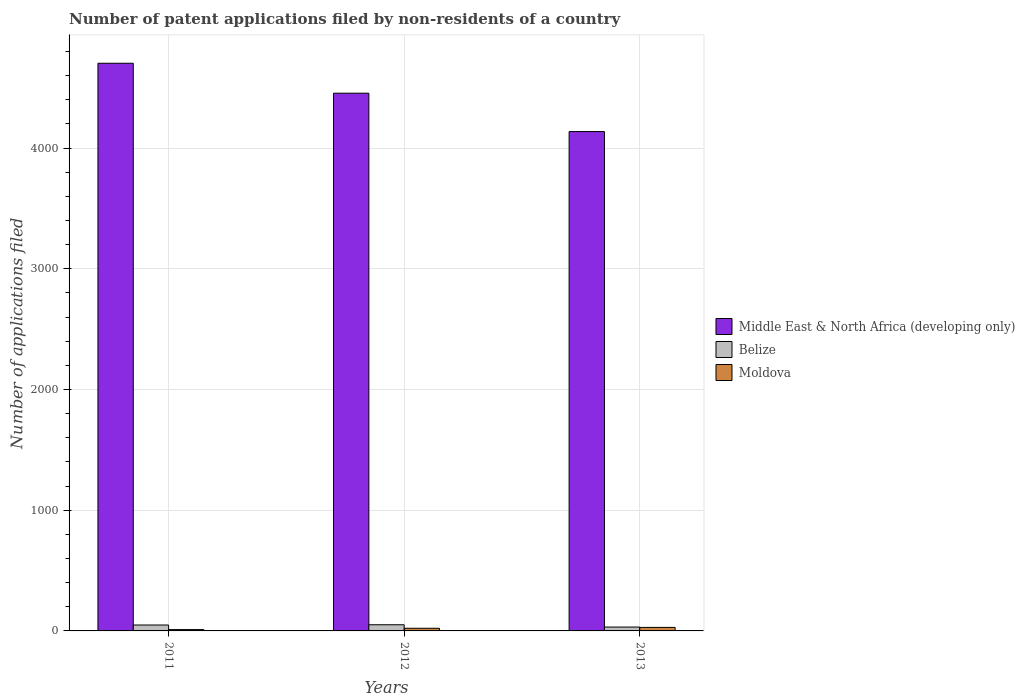How many groups of bars are there?
Keep it short and to the point. 3. What is the number of applications filed in Belize in 2011?
Ensure brevity in your answer.  49. Across all years, what is the maximum number of applications filed in Middle East & North Africa (developing only)?
Give a very brief answer. 4703. Across all years, what is the minimum number of applications filed in Middle East & North Africa (developing only)?
Keep it short and to the point. 4137. In which year was the number of applications filed in Moldova maximum?
Provide a succinct answer. 2013. In which year was the number of applications filed in Belize minimum?
Make the answer very short. 2013. What is the total number of applications filed in Middle East & North Africa (developing only) in the graph?
Offer a very short reply. 1.33e+04. What is the difference between the number of applications filed in Belize in 2011 and that in 2012?
Give a very brief answer. -2. What is the difference between the number of applications filed in Belize in 2011 and the number of applications filed in Middle East & North Africa (developing only) in 2013?
Your answer should be compact. -4088. What is the average number of applications filed in Belize per year?
Offer a terse response. 44. In the year 2011, what is the difference between the number of applications filed in Moldova and number of applications filed in Belize?
Give a very brief answer. -38. What is the ratio of the number of applications filed in Middle East & North Africa (developing only) in 2012 to that in 2013?
Ensure brevity in your answer.  1.08. Is the number of applications filed in Middle East & North Africa (developing only) in 2011 less than that in 2012?
Offer a very short reply. No. What is the difference between the highest and the second highest number of applications filed in Middle East & North Africa (developing only)?
Provide a succinct answer. 248. What does the 1st bar from the left in 2012 represents?
Make the answer very short. Middle East & North Africa (developing only). What does the 1st bar from the right in 2012 represents?
Provide a succinct answer. Moldova. Is it the case that in every year, the sum of the number of applications filed in Belize and number of applications filed in Middle East & North Africa (developing only) is greater than the number of applications filed in Moldova?
Keep it short and to the point. Yes. How many bars are there?
Offer a very short reply. 9. Are all the bars in the graph horizontal?
Offer a terse response. No. How many years are there in the graph?
Provide a succinct answer. 3. Does the graph contain any zero values?
Provide a short and direct response. No. Does the graph contain grids?
Your answer should be compact. Yes. What is the title of the graph?
Your response must be concise. Number of patent applications filed by non-residents of a country. What is the label or title of the X-axis?
Provide a short and direct response. Years. What is the label or title of the Y-axis?
Your answer should be compact. Number of applications filed. What is the Number of applications filed of Middle East & North Africa (developing only) in 2011?
Your response must be concise. 4703. What is the Number of applications filed of Moldova in 2011?
Keep it short and to the point. 11. What is the Number of applications filed in Middle East & North Africa (developing only) in 2012?
Your answer should be compact. 4455. What is the Number of applications filed of Belize in 2012?
Your answer should be very brief. 51. What is the Number of applications filed of Moldova in 2012?
Ensure brevity in your answer.  22. What is the Number of applications filed of Middle East & North Africa (developing only) in 2013?
Offer a terse response. 4137. What is the Number of applications filed in Belize in 2013?
Offer a terse response. 32. Across all years, what is the maximum Number of applications filed of Middle East & North Africa (developing only)?
Keep it short and to the point. 4703. Across all years, what is the maximum Number of applications filed in Belize?
Offer a terse response. 51. Across all years, what is the minimum Number of applications filed in Middle East & North Africa (developing only)?
Make the answer very short. 4137. Across all years, what is the minimum Number of applications filed in Belize?
Your response must be concise. 32. What is the total Number of applications filed of Middle East & North Africa (developing only) in the graph?
Your answer should be very brief. 1.33e+04. What is the total Number of applications filed of Belize in the graph?
Make the answer very short. 132. What is the total Number of applications filed of Moldova in the graph?
Your answer should be very brief. 62. What is the difference between the Number of applications filed of Middle East & North Africa (developing only) in 2011 and that in 2012?
Your answer should be compact. 248. What is the difference between the Number of applications filed of Middle East & North Africa (developing only) in 2011 and that in 2013?
Your answer should be very brief. 566. What is the difference between the Number of applications filed in Moldova in 2011 and that in 2013?
Provide a succinct answer. -18. What is the difference between the Number of applications filed in Middle East & North Africa (developing only) in 2012 and that in 2013?
Make the answer very short. 318. What is the difference between the Number of applications filed in Moldova in 2012 and that in 2013?
Give a very brief answer. -7. What is the difference between the Number of applications filed of Middle East & North Africa (developing only) in 2011 and the Number of applications filed of Belize in 2012?
Your answer should be very brief. 4652. What is the difference between the Number of applications filed of Middle East & North Africa (developing only) in 2011 and the Number of applications filed of Moldova in 2012?
Offer a very short reply. 4681. What is the difference between the Number of applications filed in Middle East & North Africa (developing only) in 2011 and the Number of applications filed in Belize in 2013?
Your answer should be compact. 4671. What is the difference between the Number of applications filed of Middle East & North Africa (developing only) in 2011 and the Number of applications filed of Moldova in 2013?
Your answer should be compact. 4674. What is the difference between the Number of applications filed of Belize in 2011 and the Number of applications filed of Moldova in 2013?
Provide a succinct answer. 20. What is the difference between the Number of applications filed of Middle East & North Africa (developing only) in 2012 and the Number of applications filed of Belize in 2013?
Make the answer very short. 4423. What is the difference between the Number of applications filed in Middle East & North Africa (developing only) in 2012 and the Number of applications filed in Moldova in 2013?
Ensure brevity in your answer.  4426. What is the average Number of applications filed of Middle East & North Africa (developing only) per year?
Give a very brief answer. 4431.67. What is the average Number of applications filed of Belize per year?
Your response must be concise. 44. What is the average Number of applications filed of Moldova per year?
Offer a very short reply. 20.67. In the year 2011, what is the difference between the Number of applications filed of Middle East & North Africa (developing only) and Number of applications filed of Belize?
Your answer should be compact. 4654. In the year 2011, what is the difference between the Number of applications filed in Middle East & North Africa (developing only) and Number of applications filed in Moldova?
Ensure brevity in your answer.  4692. In the year 2011, what is the difference between the Number of applications filed in Belize and Number of applications filed in Moldova?
Ensure brevity in your answer.  38. In the year 2012, what is the difference between the Number of applications filed of Middle East & North Africa (developing only) and Number of applications filed of Belize?
Your answer should be compact. 4404. In the year 2012, what is the difference between the Number of applications filed of Middle East & North Africa (developing only) and Number of applications filed of Moldova?
Your answer should be very brief. 4433. In the year 2012, what is the difference between the Number of applications filed in Belize and Number of applications filed in Moldova?
Offer a terse response. 29. In the year 2013, what is the difference between the Number of applications filed in Middle East & North Africa (developing only) and Number of applications filed in Belize?
Your answer should be very brief. 4105. In the year 2013, what is the difference between the Number of applications filed of Middle East & North Africa (developing only) and Number of applications filed of Moldova?
Your response must be concise. 4108. What is the ratio of the Number of applications filed in Middle East & North Africa (developing only) in 2011 to that in 2012?
Provide a succinct answer. 1.06. What is the ratio of the Number of applications filed of Belize in 2011 to that in 2012?
Provide a succinct answer. 0.96. What is the ratio of the Number of applications filed in Moldova in 2011 to that in 2012?
Keep it short and to the point. 0.5. What is the ratio of the Number of applications filed in Middle East & North Africa (developing only) in 2011 to that in 2013?
Your response must be concise. 1.14. What is the ratio of the Number of applications filed of Belize in 2011 to that in 2013?
Offer a very short reply. 1.53. What is the ratio of the Number of applications filed of Moldova in 2011 to that in 2013?
Offer a very short reply. 0.38. What is the ratio of the Number of applications filed in Middle East & North Africa (developing only) in 2012 to that in 2013?
Make the answer very short. 1.08. What is the ratio of the Number of applications filed in Belize in 2012 to that in 2013?
Keep it short and to the point. 1.59. What is the ratio of the Number of applications filed of Moldova in 2012 to that in 2013?
Give a very brief answer. 0.76. What is the difference between the highest and the second highest Number of applications filed of Middle East & North Africa (developing only)?
Your answer should be compact. 248. What is the difference between the highest and the second highest Number of applications filed in Belize?
Your answer should be very brief. 2. What is the difference between the highest and the second highest Number of applications filed in Moldova?
Your response must be concise. 7. What is the difference between the highest and the lowest Number of applications filed in Middle East & North Africa (developing only)?
Your answer should be compact. 566. What is the difference between the highest and the lowest Number of applications filed of Moldova?
Ensure brevity in your answer.  18. 